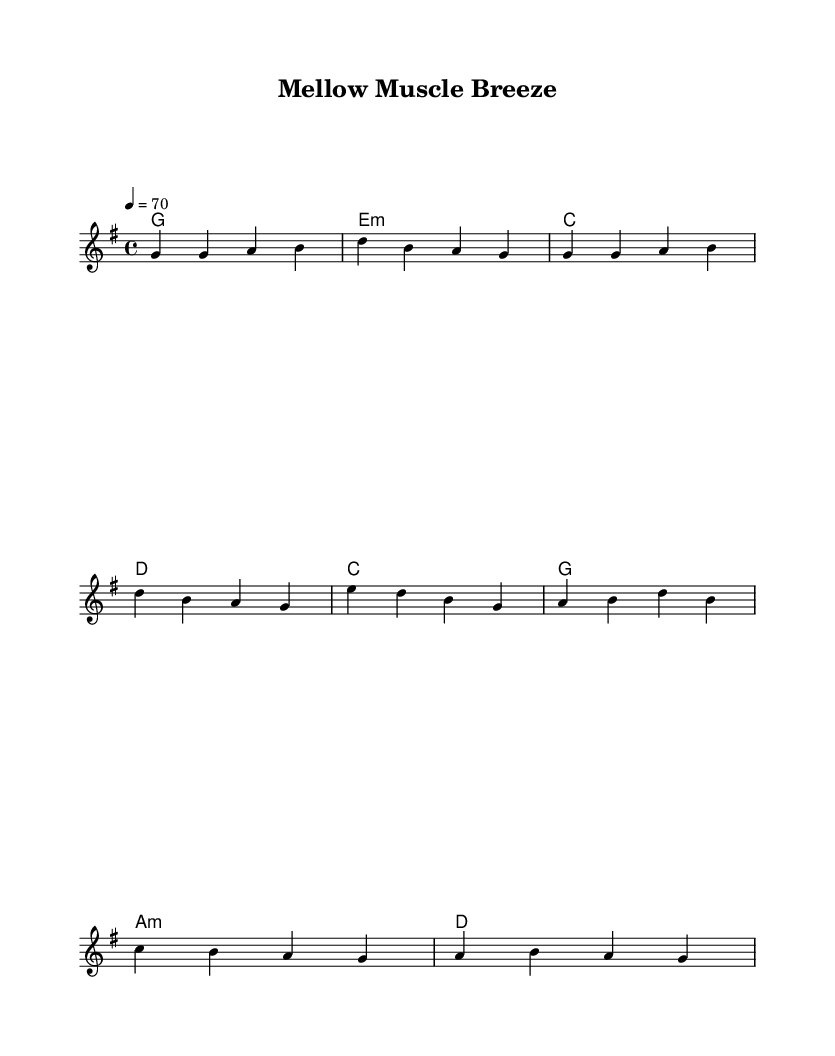What is the key signature of this music? The key signature is G major, which has one sharp (F#).
Answer: G major What is the time signature of this music? The time signature is 4/4, which means there are four beats in each measure and the quarter note gets one beat.
Answer: 4/4 What is the tempo marking of this music? The tempo marking indicates a speed of 70 beats per minute, which suggests a relaxed and laid-back feel appropriate for recovery.
Answer: 70 What musical form does this piece primarily use? The piece utilizes a verse-chorus form, where distinct sections are repeated, creating a familiar structure throughout the music.
Answer: Verse-chorus How many measures are in the verse section? The verse section consists of 4 measures, as indicated by the grouping of notes.
Answer: 4 What is the first chord of the song? The first chord is G major, which is clearly indicated in the chord names right above the staff.
Answer: G What genre does this music belong to? This piece falls under the reggae genre, characterized by its relaxed tempo and rhythmic emphasis, which is fitting for post-workout recovery.
Answer: Reggae 